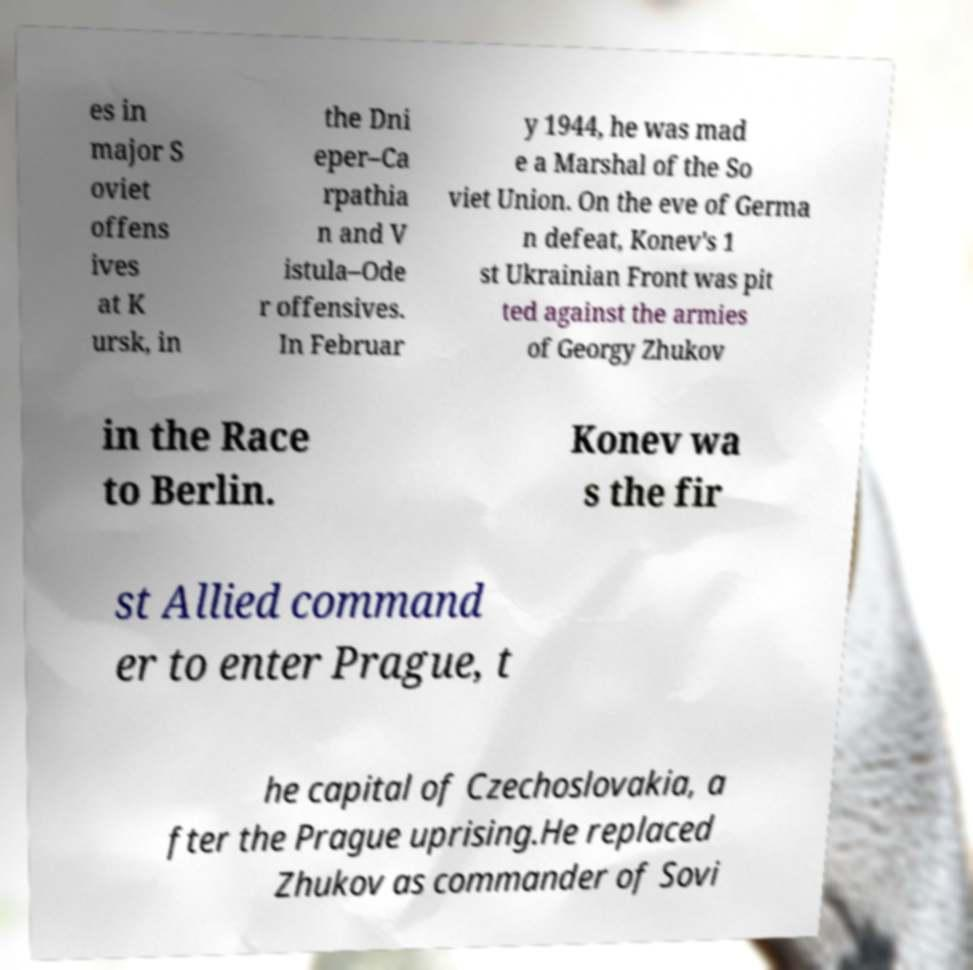Please read and relay the text visible in this image. What does it say? es in major S oviet offens ives at K ursk, in the Dni eper–Ca rpathia n and V istula–Ode r offensives. In Februar y 1944, he was mad e a Marshal of the So viet Union. On the eve of Germa n defeat, Konev's 1 st Ukrainian Front was pit ted against the armies of Georgy Zhukov in the Race to Berlin. Konev wa s the fir st Allied command er to enter Prague, t he capital of Czechoslovakia, a fter the Prague uprising.He replaced Zhukov as commander of Sovi 